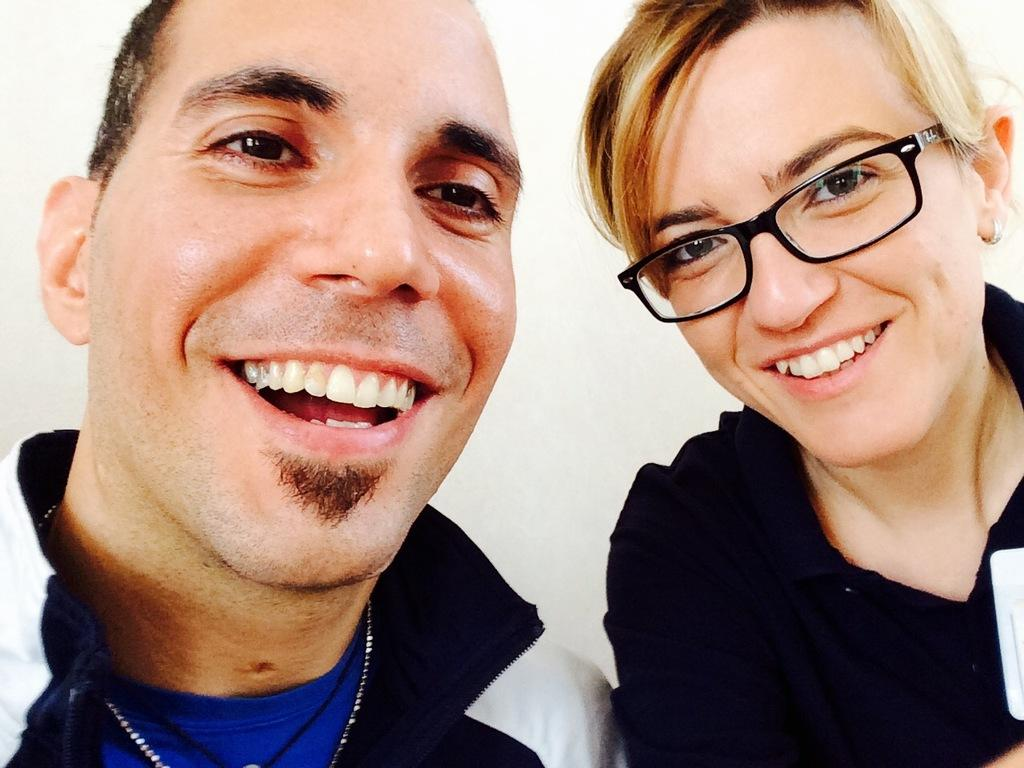How many people are in the image? There are two persons in the image. What colors are featured in the clothing of the first person? The first person is wearing a blue shirt and jacket. What color is the jacket of the second person? The second person is wearing a black jacket. What is the color of the background in the image? The background of the image is white. How many homes are visible in the image? There are no homes visible in the image; it only features two persons and their jackets. What is the cause of death for the person in the black jacket? There is no information about the cause of death for any person in the image, as it only shows two people and their clothing. 